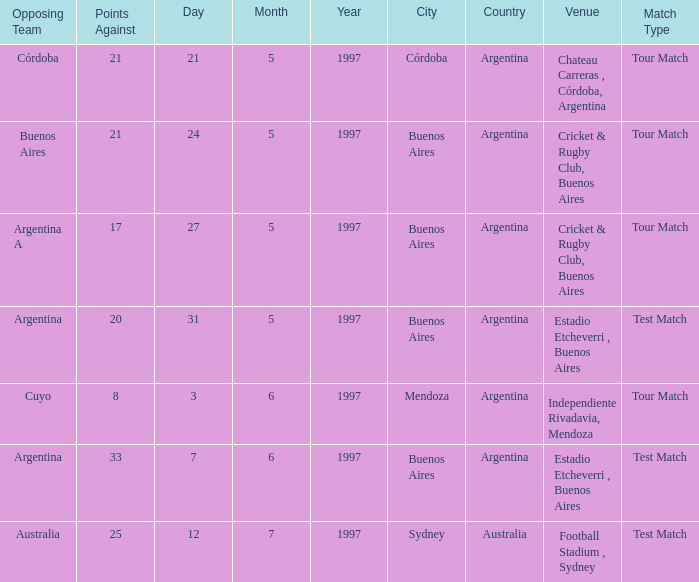Which venue has an against value larger than 21 and had Argentina as an opposing team. Estadio Etcheverri , Buenos Aires. 